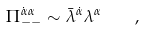Convert formula to latex. <formula><loc_0><loc_0><loc_500><loc_500>\Pi ^ { \dot { \alpha } \alpha } _ { - - } \sim \bar { \lambda } ^ { \dot { \alpha } } \lambda ^ { \alpha } \quad ,</formula> 